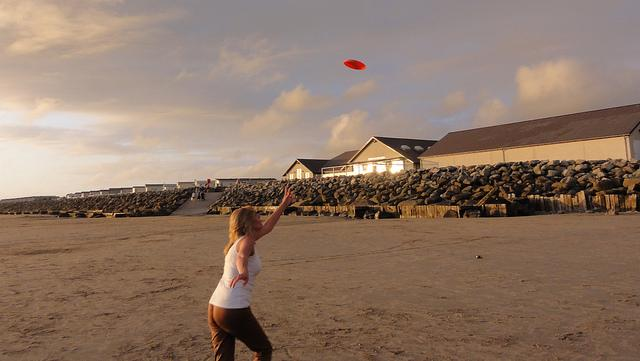What cut of shirt is she wearing? Please explain your reasoning. tank top. She has on a white tank top. 